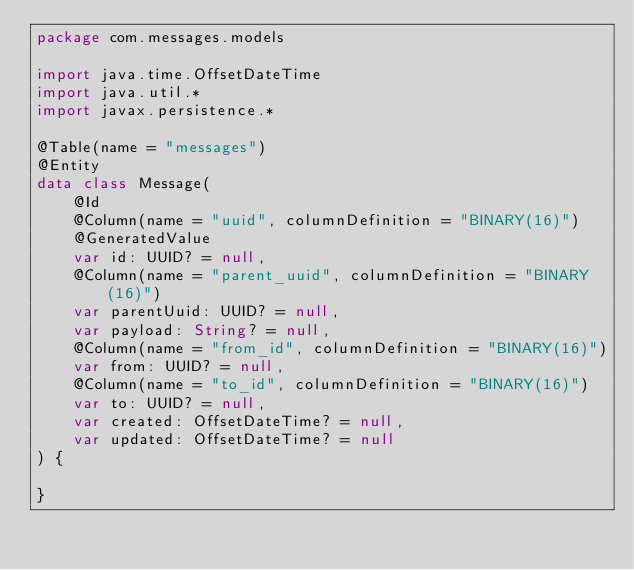<code> <loc_0><loc_0><loc_500><loc_500><_Kotlin_>package com.messages.models

import java.time.OffsetDateTime
import java.util.*
import javax.persistence.*

@Table(name = "messages")
@Entity
data class Message(
    @Id
    @Column(name = "uuid", columnDefinition = "BINARY(16)")
    @GeneratedValue
    var id: UUID? = null,
    @Column(name = "parent_uuid", columnDefinition = "BINARY(16)")
    var parentUuid: UUID? = null,
    var payload: String? = null,
    @Column(name = "from_id", columnDefinition = "BINARY(16)")
    var from: UUID? = null,
    @Column(name = "to_id", columnDefinition = "BINARY(16)")
    var to: UUID? = null,
    var created: OffsetDateTime? = null,
    var updated: OffsetDateTime? = null
) {

}</code> 